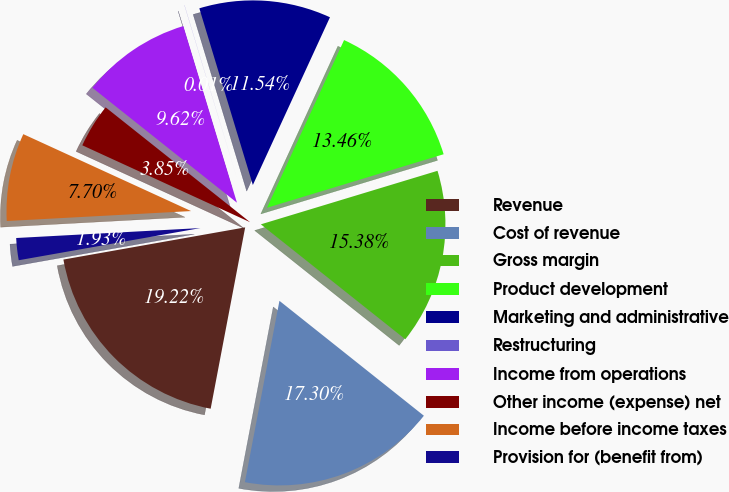<chart> <loc_0><loc_0><loc_500><loc_500><pie_chart><fcel>Revenue<fcel>Cost of revenue<fcel>Gross margin<fcel>Product development<fcel>Marketing and administrative<fcel>Restructuring<fcel>Income from operations<fcel>Other income (expense) net<fcel>Income before income taxes<fcel>Provision for (benefit from)<nl><fcel>19.22%<fcel>17.3%<fcel>15.38%<fcel>13.46%<fcel>11.54%<fcel>0.01%<fcel>9.62%<fcel>3.85%<fcel>7.7%<fcel>1.93%<nl></chart> 